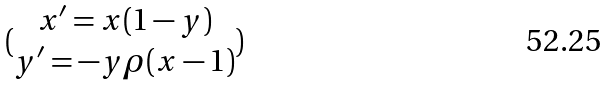Convert formula to latex. <formula><loc_0><loc_0><loc_500><loc_500>( \begin{matrix} x ^ { \prime } = x ( 1 - y ) \\ y ^ { \prime } = - y \rho ( x - 1 ) \end{matrix} )</formula> 